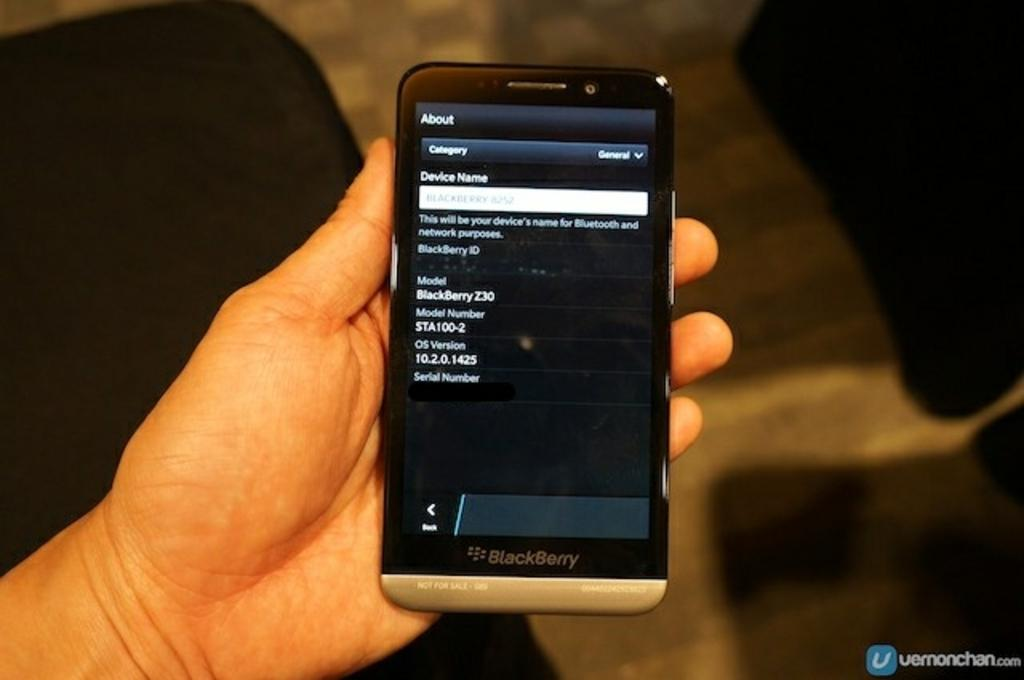<image>
Give a short and clear explanation of the subsequent image. A blackberry device showing the device name, model number, and other information on the screen. 